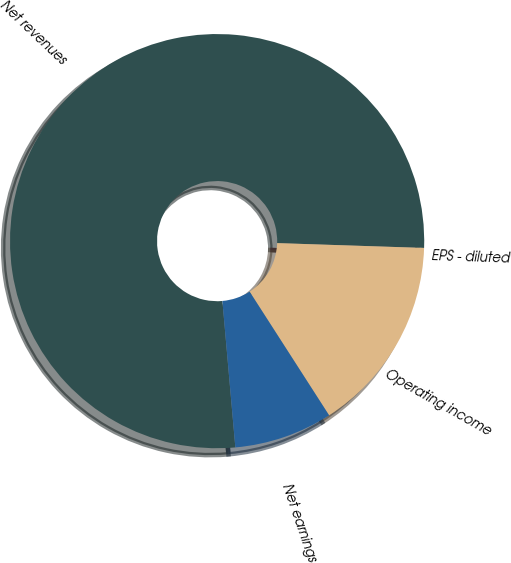Convert chart to OTSL. <chart><loc_0><loc_0><loc_500><loc_500><pie_chart><fcel>Net revenues<fcel>EPS - diluted<fcel>Operating income<fcel>Net earnings<nl><fcel>76.92%<fcel>0.0%<fcel>15.38%<fcel>7.69%<nl></chart> 